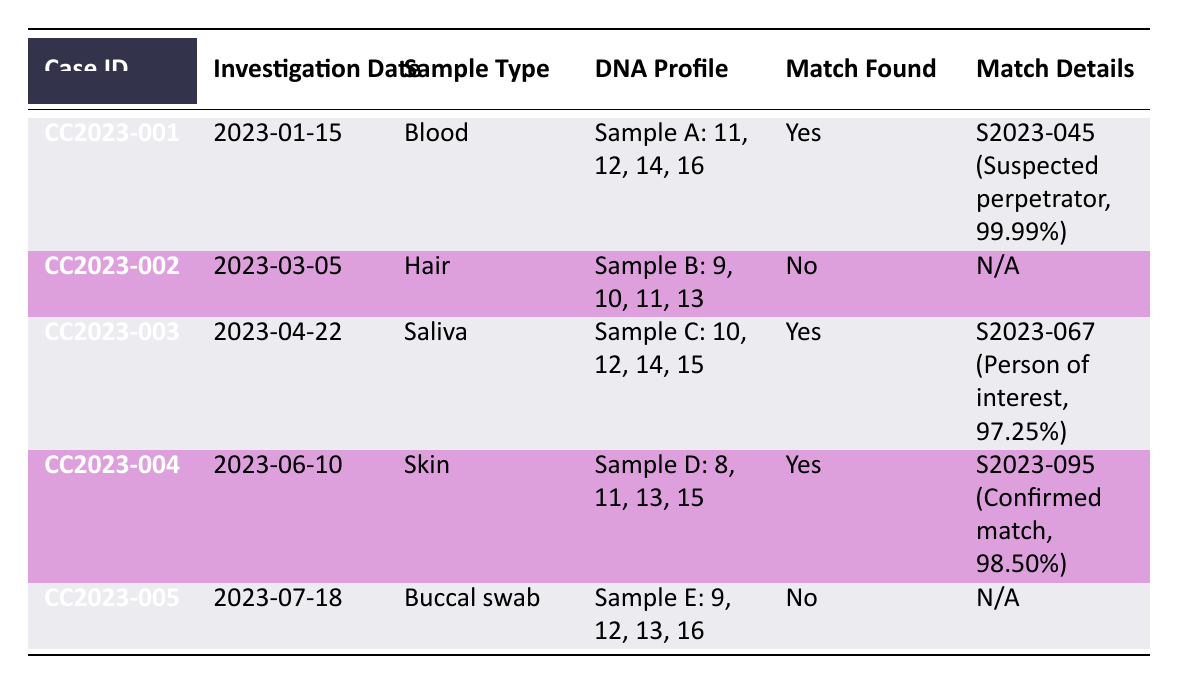What is the sample type for case ID CC2023-003? In the table, the sample type for case ID CC2023-003 is specified under the "Sample Type" column. Looking at the row for this case, it shows "Saliva".
Answer: Saliva How many cases had a match found? The table indicates match found statuses under the "Match Found" column. By reviewing the rows, three cases (CC2023-001, CC2023-003, and CC2023-004) indicate "Yes" for a match found.
Answer: 3 What is the relationship of the suspect in case CC2023-001? The relationship is provided in the "Match Details" section for the case CC2023-001. According to the table, the suspect relationship is noted as "Suspected perpetrator".
Answer: Suspected perpetrator Are there any cases where DNA profiles did not result in a match? The "Match Found" column indicates cases where no match was found. In the table, CC2023-002 and CC2023-005 are marked as "No" for match found.
Answer: Yes What is the average match probability for cases with a match found? To find the average match probability, we need to consider only the cases with a match: CC2023-001 (99.99%), CC2023-003 (97.25%), and CC2023-004 (98.50%). First, we sum these probabilities: 99.99 + 97.25 + 98.50 = 295.74. Since there are three cases, the average is 295.74/3 = 98.58.
Answer: 98.58 Which case has the highest match probability and what is it? By reviewing the "Match Details" in the table, we compare the match probabilities for the cases with a match. CC2023-001 has 99.99%, CC2023-003 has 97.25%, and CC2023-004 has 98.50%. The highest is 99.99% from case CC2023-001.
Answer: CC2023-001, 99.99% Is there a case with a match found from a sample collected in the 1980s? We need to check the "Sample Collection Date" column for any samples collected in the 1980s while also confirming "Match Found" is "Yes." CC2023-003 has a sample collection date of 1988-11-30 and indicates a match found.
Answer: Yes How many different sample types are present in the table? The table provides sample types under the "Sample Type" column. Reviewing the entries shows Blood, Hair, Saliva, Skin, and Buccal swab. Therefore, there are five distinct sample types.
Answer: 5 What was the investigation date for the case with the confirmed match? The investigation date for the case with a confirmed match can be found in the "Investigation Date" column for CC2023-004. It shows the date as 2023-06-10.
Answer: 2023-06-10 